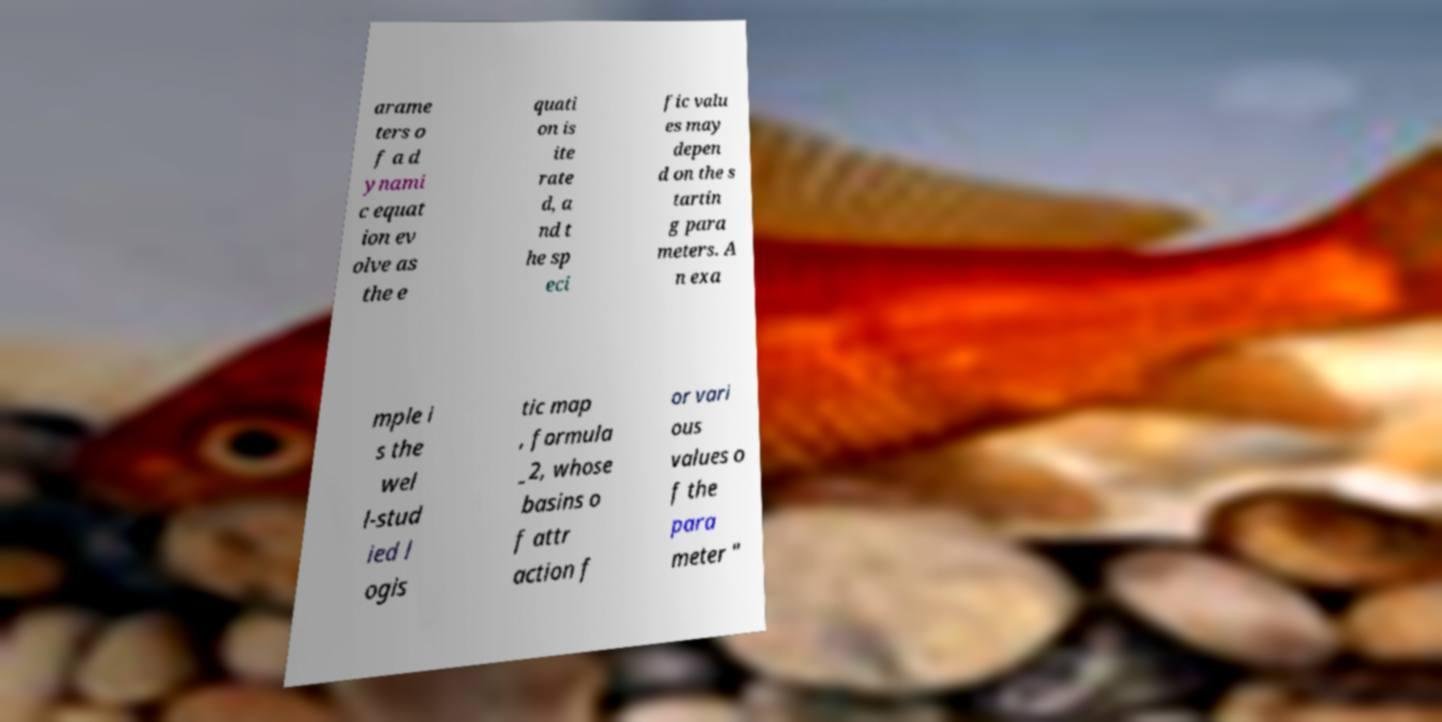Please read and relay the text visible in this image. What does it say? arame ters o f a d ynami c equat ion ev olve as the e quati on is ite rate d, a nd t he sp eci fic valu es may depen d on the s tartin g para meters. A n exa mple i s the wel l-stud ied l ogis tic map , formula _2, whose basins o f attr action f or vari ous values o f the para meter " 